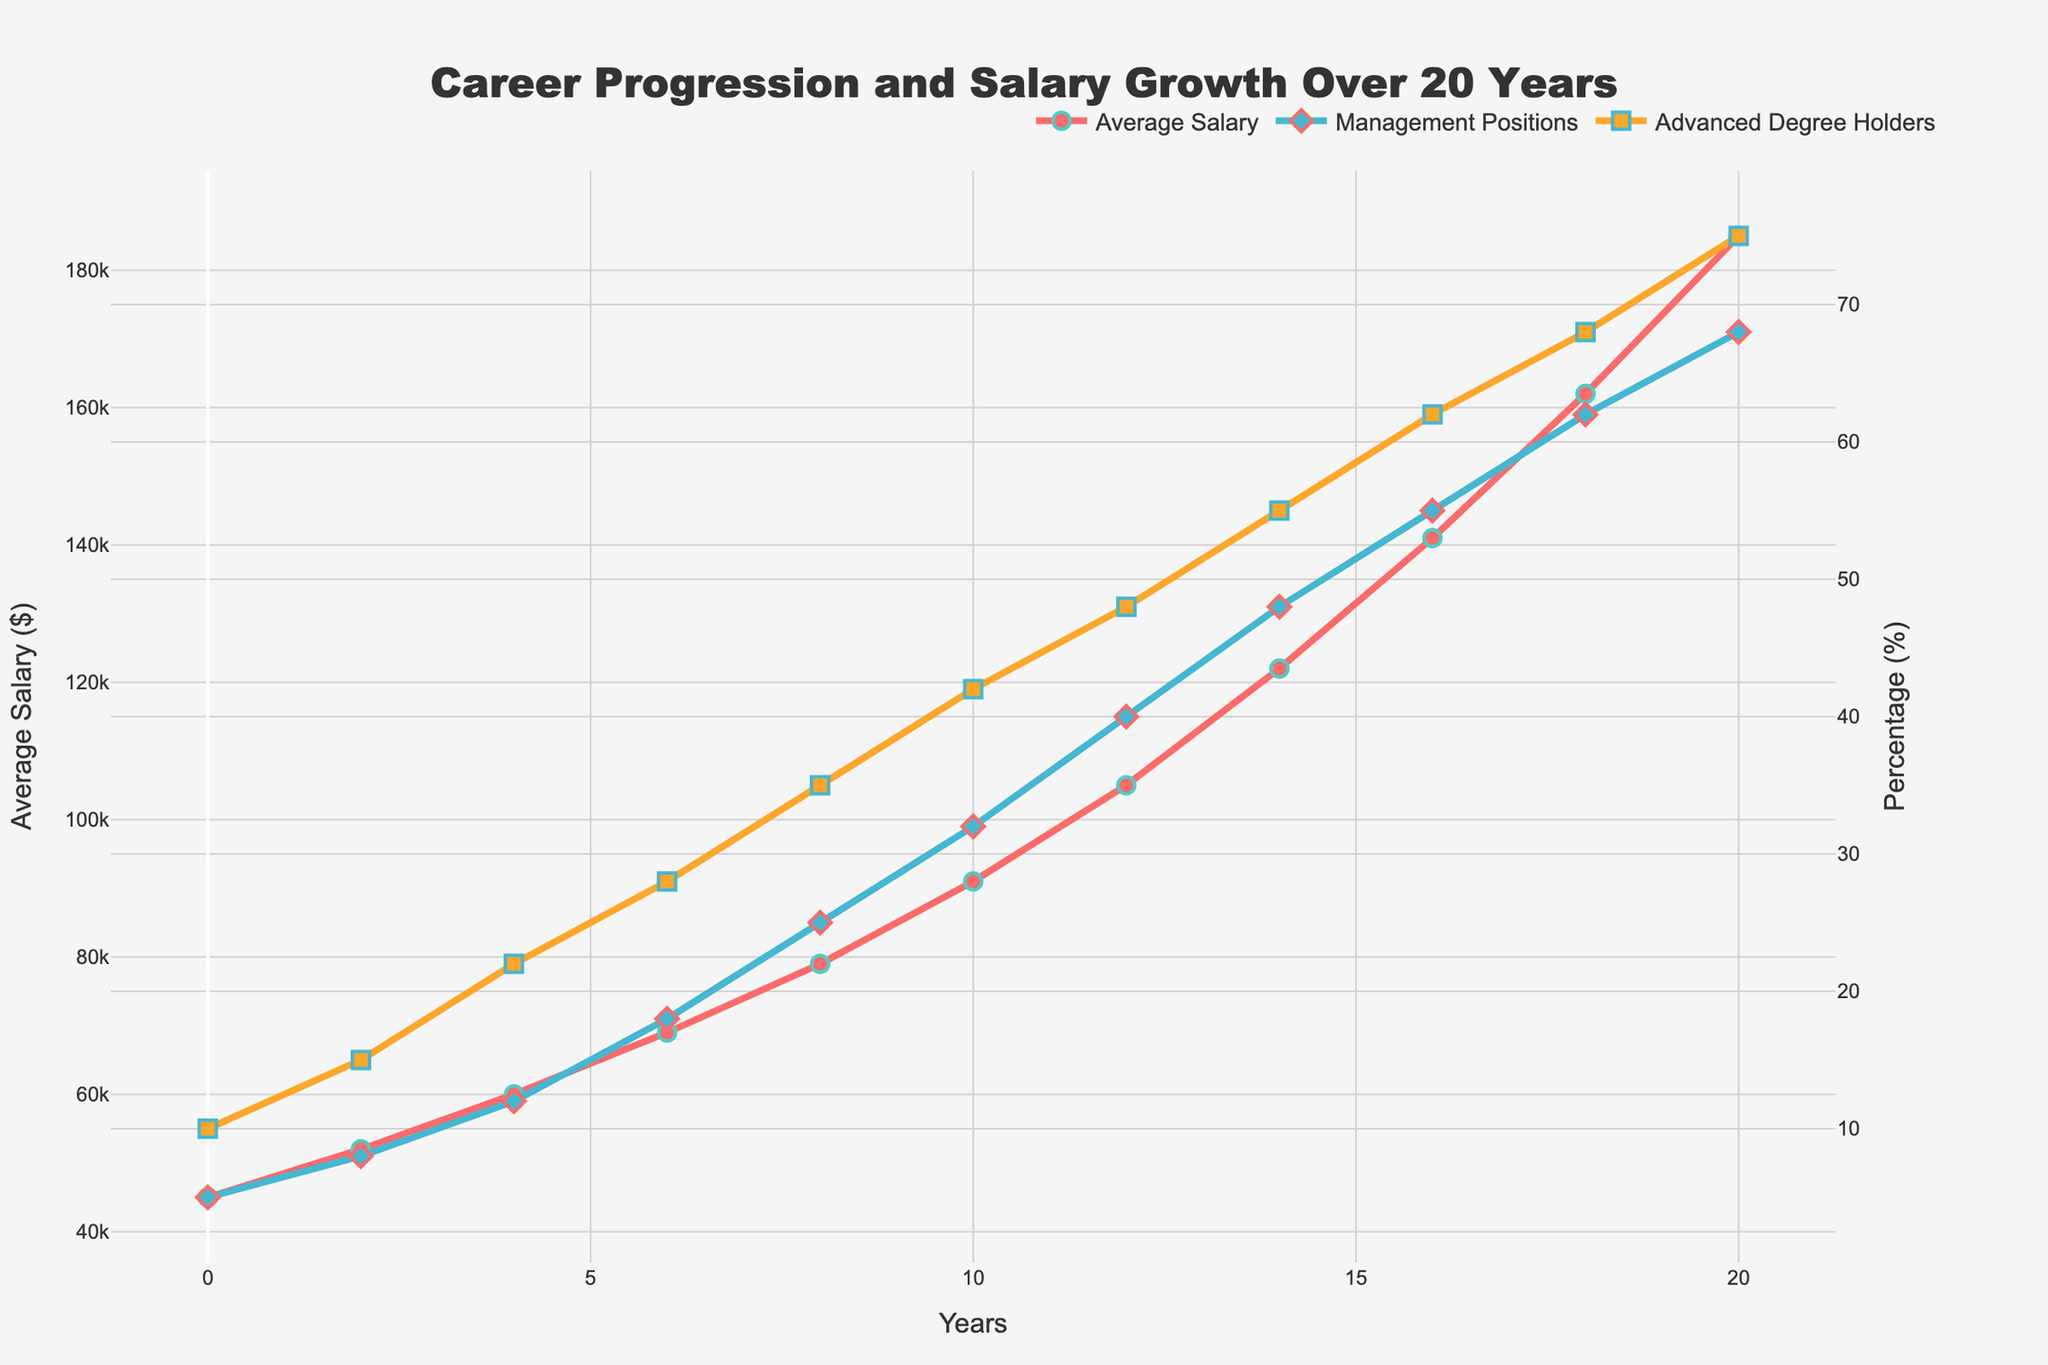What is the average salary after 10 years? To determine the average salary after 10 years, look at the data point on the "Average Salary ($)" line at the 10-year mark. The value is 91,000.
Answer: 91,000 How much has the percentage of management positions increased from year 0 to year 10? To find the increase, subtract the percentage at year 0 from the percentage at year 10 for "Management Positions (%)", which are 5% and 32% respectively. The increase is 32% - 5% = 27%.
Answer: 27% What is the difference between the salary at year 20 and year 0? Subtract the salary at year 0 from the salary at year 20. The values are $45,000 and $185,000 respectively. So, the difference is $185,000 - $45,000 = $140,000.
Answer: 140,000 Which year shows the highest increase in "Advanced Degree Holders (%)" compared to the previous period? By examining the slope changes between each year in the "Advanced Degree Holders (%)" line, the largest increase in a single period occurs between years 0 and 2, where the percentage increases from 10% to 15%.
Answer: Year 2 At what point does the average salary surpass $100,000? Look at the "Average Salary ($)" line plot to see when the salary first exceeds $100,000. This happens at year 12 with an average salary of $105,000.
Answer: Year 12 How does the trend of "Management Positions (%)" compare to "Advanced Degree Holders (%)" over the 20 years? Both show an increasing trend over the 20 years, but "Management Positions (%)" starts low and catches up with "Advanced Degree Holders (%)" by the end of the period. Initially, advanced degree holders are higher as both grow but management positions grow faster.
Answer: Both increase, management positions grow faster If you combine the average values of "Management Positions (%)" and "Advanced Degree Holders (%)" at year 4, what is the result? Add the values of "Management Positions (%)" and "Advanced Degree Holders (%)" at year 4, which are 12% and 22% respectively. The combined average is (12 + 22) / 2 = 17%.
Answer: 17% Which color represents the "Average Salary" trend in the chart? The chart shows "Average Salary ($)" represented by the red line.
Answer: Red Does any data point show the "Advanced Degree Holders (%)" percentage being equal to "Management Positions (%)"? Examine both lines to see if they intersect at any point. They do not intersect, indicating no point where the percentages are equal.
Answer: No From years 6 to 8, by how much does the average salary increase? Subtract the salary at year 6 from the salary at year 8. The values are $69,000 and $79,000 respectively. So, the increase is $79,000 - $69,000 = $10,000.
Answer: 10,000 